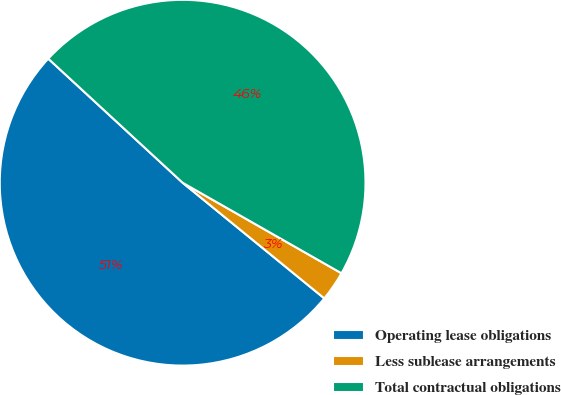Convert chart. <chart><loc_0><loc_0><loc_500><loc_500><pie_chart><fcel>Operating lease obligations<fcel>Less sublease arrangements<fcel>Total contractual obligations<nl><fcel>50.97%<fcel>2.65%<fcel>46.38%<nl></chart> 